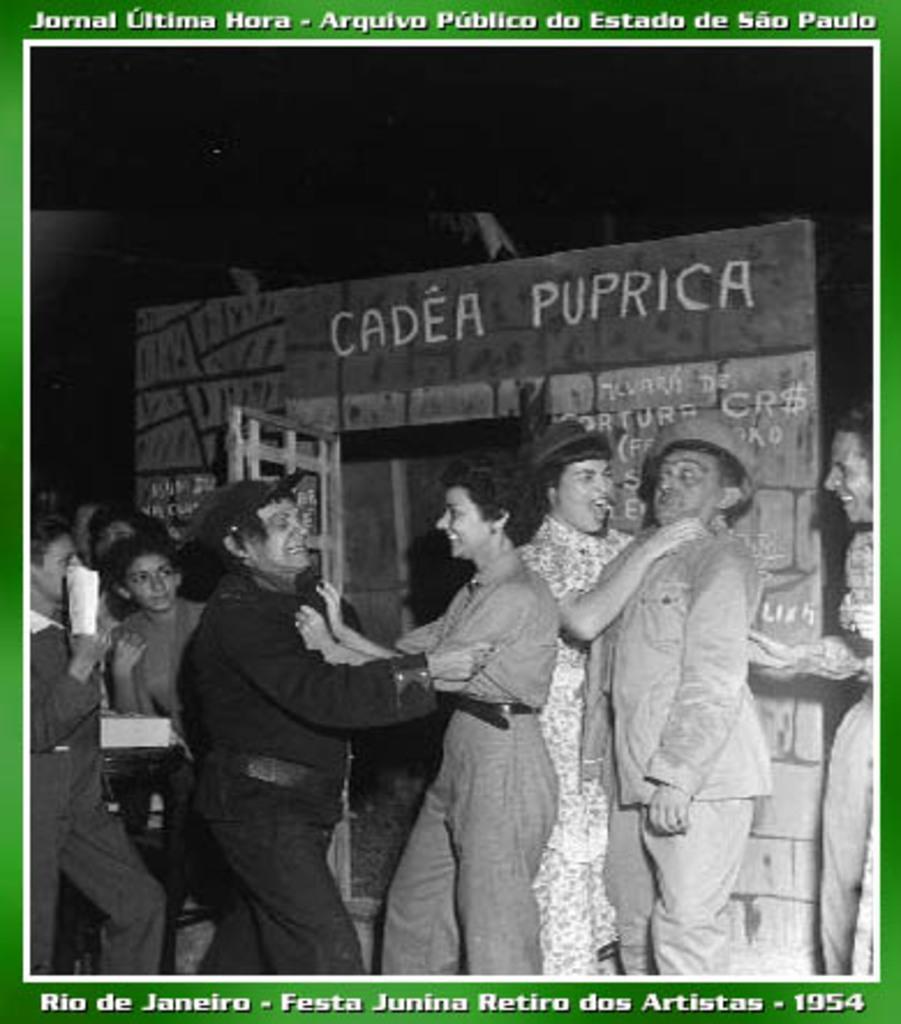How would you summarize this image in a sentence or two? In the picture I can see few persons and there is an object in the background and there is something written above and below it. 